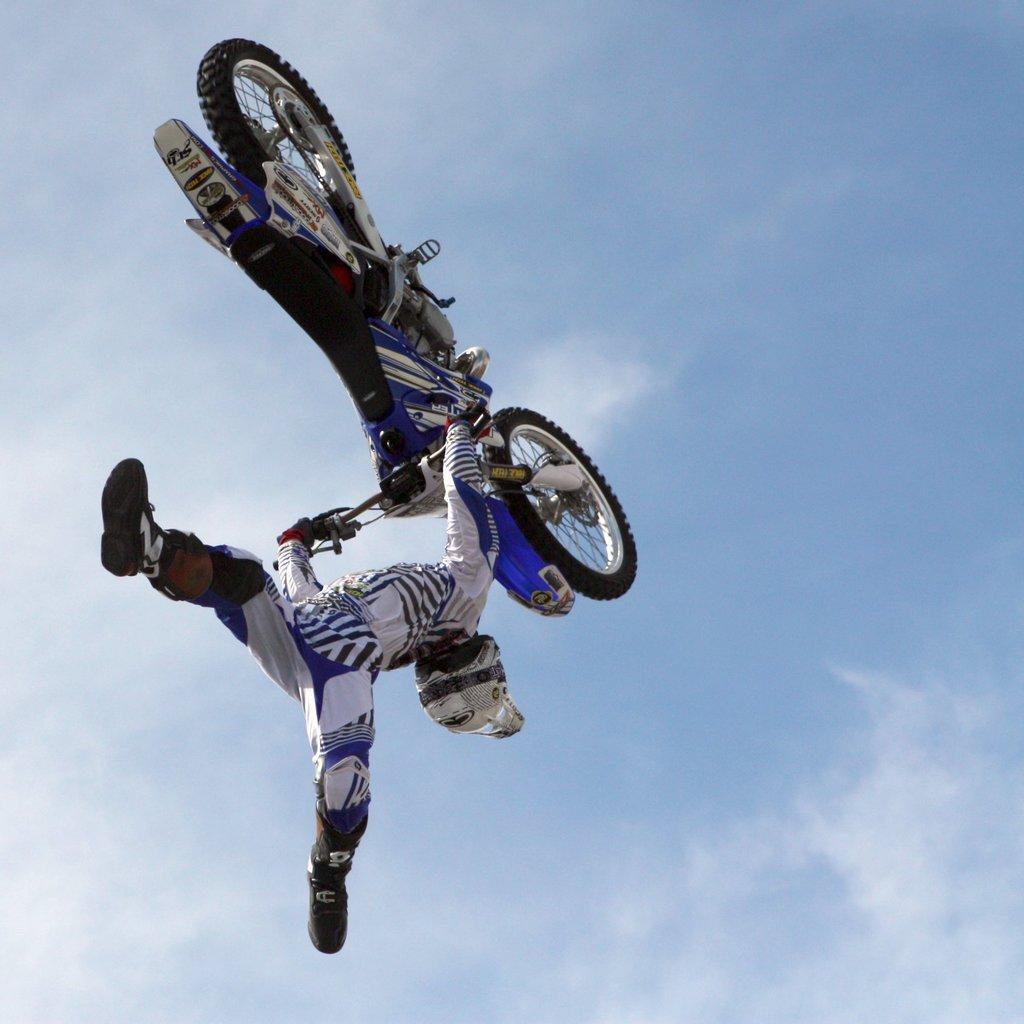Who or what is the main subject in the image? There is a person in the image. What is the person holding in the image? The person is holding a bike. What is the person doing with the bike? The person is in the air, which suggests they are performing a stunt or trick with the bike. What can be seen in the background of the image? There is sky visible in the background of the image. How many horses can be seen in the image? There are no horses present in the image. What type of balance does the person need to maintain while holding the bike in the air? The person's balance is not explicitly mentioned in the image, but it can be inferred that they need good balance to perform the stunt or trick with the bike. 